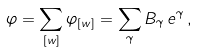Convert formula to latex. <formula><loc_0><loc_0><loc_500><loc_500>\varphi = \sum _ { [ w ] } \varphi _ { [ w ] } = \sum _ { \gamma } B _ { \gamma } \, e ^ { \gamma } \, ,</formula> 